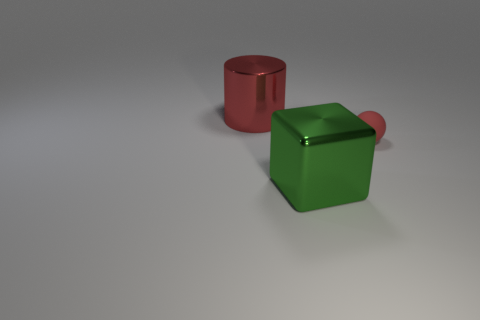Is there anything else that is the same size as the rubber thing?
Offer a very short reply. No. Is the number of objects that are to the left of the small object greater than the number of large metal cylinders?
Make the answer very short. Yes. Are any red cylinders visible?
Your answer should be very brief. Yes. What number of cylinders are the same size as the metal block?
Your answer should be compact. 1. Is the number of large metal cylinders that are in front of the tiny sphere greater than the number of big red shiny cylinders in front of the big red cylinder?
Provide a succinct answer. No. There is a object that is the same size as the red cylinder; what is its material?
Offer a terse response. Metal. What is the shape of the green shiny object?
Offer a terse response. Cube. How many blue things are large metal cubes or big rubber cylinders?
Offer a very short reply. 0. Is the material of the object in front of the small matte sphere the same as the red object that is to the right of the green thing?
Provide a short and direct response. No. How many cylinders are small things or large red objects?
Provide a succinct answer. 1. 